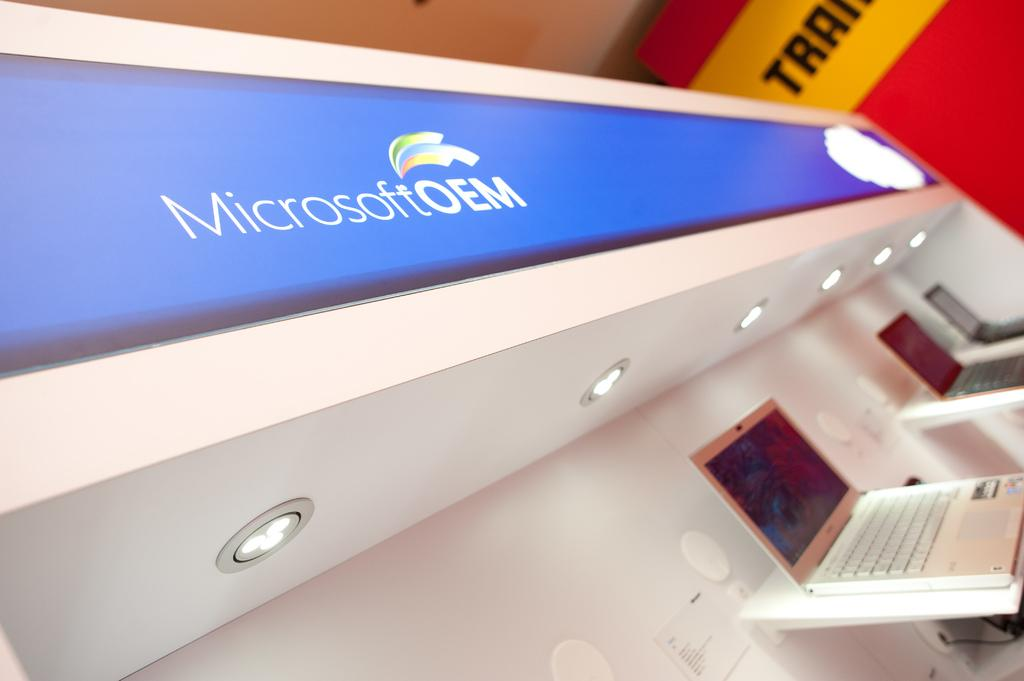Provide a one-sentence caption for the provided image. A display of different laptops under a Microsoft sign. 